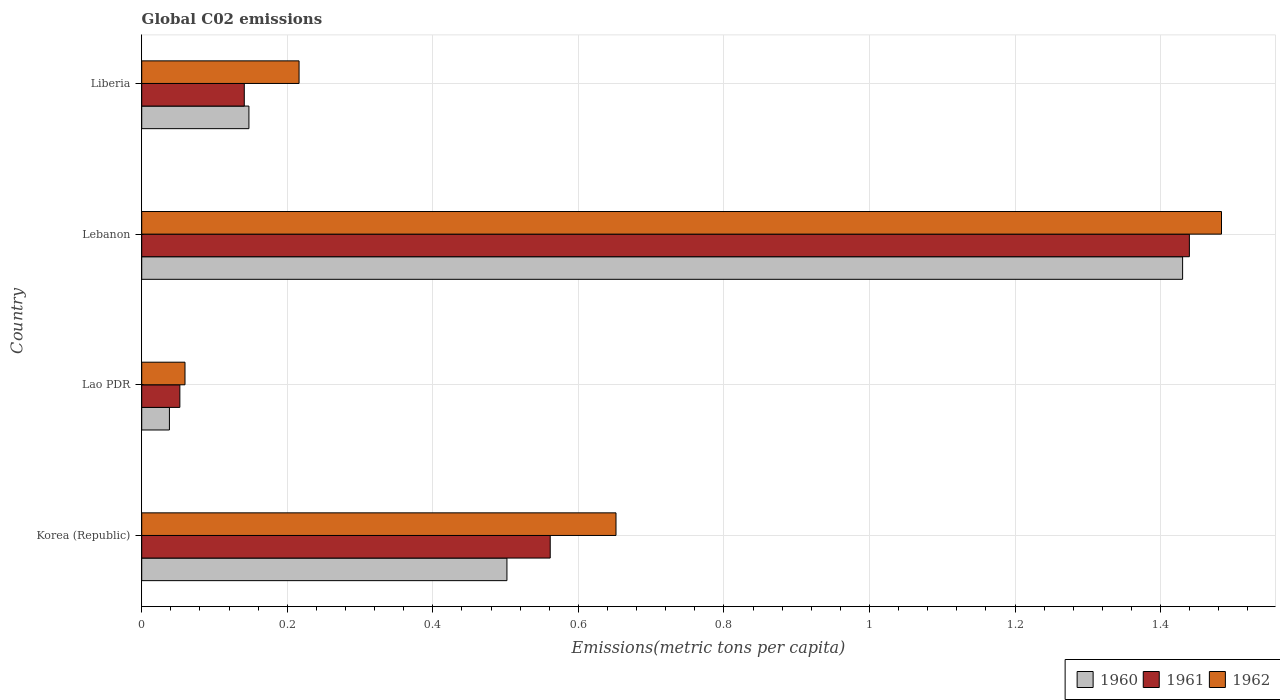Are the number of bars on each tick of the Y-axis equal?
Ensure brevity in your answer.  Yes. How many bars are there on the 2nd tick from the bottom?
Provide a succinct answer. 3. What is the amount of CO2 emitted in in 1962 in Korea (Republic)?
Keep it short and to the point. 0.65. Across all countries, what is the maximum amount of CO2 emitted in in 1960?
Keep it short and to the point. 1.43. Across all countries, what is the minimum amount of CO2 emitted in in 1962?
Keep it short and to the point. 0.06. In which country was the amount of CO2 emitted in in 1962 maximum?
Your response must be concise. Lebanon. In which country was the amount of CO2 emitted in in 1961 minimum?
Provide a short and direct response. Lao PDR. What is the total amount of CO2 emitted in in 1960 in the graph?
Give a very brief answer. 2.12. What is the difference between the amount of CO2 emitted in in 1961 in Korea (Republic) and that in Lao PDR?
Your answer should be compact. 0.51. What is the difference between the amount of CO2 emitted in in 1960 in Lebanon and the amount of CO2 emitted in in 1962 in Korea (Republic)?
Give a very brief answer. 0.78. What is the average amount of CO2 emitted in in 1961 per country?
Provide a short and direct response. 0.55. What is the difference between the amount of CO2 emitted in in 1960 and amount of CO2 emitted in in 1961 in Liberia?
Provide a short and direct response. 0.01. In how many countries, is the amount of CO2 emitted in in 1960 greater than 0.32 metric tons per capita?
Ensure brevity in your answer.  2. What is the ratio of the amount of CO2 emitted in in 1960 in Korea (Republic) to that in Lebanon?
Offer a terse response. 0.35. Is the difference between the amount of CO2 emitted in in 1960 in Lao PDR and Lebanon greater than the difference between the amount of CO2 emitted in in 1961 in Lao PDR and Lebanon?
Give a very brief answer. No. What is the difference between the highest and the second highest amount of CO2 emitted in in 1962?
Keep it short and to the point. 0.83. What is the difference between the highest and the lowest amount of CO2 emitted in in 1960?
Keep it short and to the point. 1.39. Is the sum of the amount of CO2 emitted in in 1962 in Korea (Republic) and Liberia greater than the maximum amount of CO2 emitted in in 1960 across all countries?
Provide a succinct answer. No. What does the 2nd bar from the top in Korea (Republic) represents?
Keep it short and to the point. 1961. What does the 2nd bar from the bottom in Lao PDR represents?
Your response must be concise. 1961. Are the values on the major ticks of X-axis written in scientific E-notation?
Make the answer very short. No. Does the graph contain any zero values?
Offer a terse response. No. Does the graph contain grids?
Give a very brief answer. Yes. Where does the legend appear in the graph?
Provide a short and direct response. Bottom right. How many legend labels are there?
Give a very brief answer. 3. What is the title of the graph?
Provide a short and direct response. Global C02 emissions. Does "1984" appear as one of the legend labels in the graph?
Offer a terse response. No. What is the label or title of the X-axis?
Keep it short and to the point. Emissions(metric tons per capita). What is the label or title of the Y-axis?
Your answer should be compact. Country. What is the Emissions(metric tons per capita) of 1960 in Korea (Republic)?
Ensure brevity in your answer.  0.5. What is the Emissions(metric tons per capita) in 1961 in Korea (Republic)?
Keep it short and to the point. 0.56. What is the Emissions(metric tons per capita) of 1962 in Korea (Republic)?
Ensure brevity in your answer.  0.65. What is the Emissions(metric tons per capita) of 1960 in Lao PDR?
Offer a very short reply. 0.04. What is the Emissions(metric tons per capita) in 1961 in Lao PDR?
Give a very brief answer. 0.05. What is the Emissions(metric tons per capita) of 1962 in Lao PDR?
Give a very brief answer. 0.06. What is the Emissions(metric tons per capita) of 1960 in Lebanon?
Provide a succinct answer. 1.43. What is the Emissions(metric tons per capita) of 1961 in Lebanon?
Give a very brief answer. 1.44. What is the Emissions(metric tons per capita) of 1962 in Lebanon?
Your answer should be very brief. 1.48. What is the Emissions(metric tons per capita) in 1960 in Liberia?
Ensure brevity in your answer.  0.15. What is the Emissions(metric tons per capita) of 1961 in Liberia?
Provide a succinct answer. 0.14. What is the Emissions(metric tons per capita) of 1962 in Liberia?
Offer a terse response. 0.22. Across all countries, what is the maximum Emissions(metric tons per capita) in 1960?
Your response must be concise. 1.43. Across all countries, what is the maximum Emissions(metric tons per capita) of 1961?
Provide a succinct answer. 1.44. Across all countries, what is the maximum Emissions(metric tons per capita) of 1962?
Ensure brevity in your answer.  1.48. Across all countries, what is the minimum Emissions(metric tons per capita) in 1960?
Make the answer very short. 0.04. Across all countries, what is the minimum Emissions(metric tons per capita) in 1961?
Keep it short and to the point. 0.05. Across all countries, what is the minimum Emissions(metric tons per capita) in 1962?
Offer a terse response. 0.06. What is the total Emissions(metric tons per capita) of 1960 in the graph?
Offer a very short reply. 2.12. What is the total Emissions(metric tons per capita) of 1961 in the graph?
Give a very brief answer. 2.19. What is the total Emissions(metric tons per capita) in 1962 in the graph?
Make the answer very short. 2.41. What is the difference between the Emissions(metric tons per capita) of 1960 in Korea (Republic) and that in Lao PDR?
Provide a succinct answer. 0.46. What is the difference between the Emissions(metric tons per capita) of 1961 in Korea (Republic) and that in Lao PDR?
Ensure brevity in your answer.  0.51. What is the difference between the Emissions(metric tons per capita) in 1962 in Korea (Republic) and that in Lao PDR?
Provide a short and direct response. 0.59. What is the difference between the Emissions(metric tons per capita) of 1960 in Korea (Republic) and that in Lebanon?
Ensure brevity in your answer.  -0.93. What is the difference between the Emissions(metric tons per capita) of 1961 in Korea (Republic) and that in Lebanon?
Provide a succinct answer. -0.88. What is the difference between the Emissions(metric tons per capita) of 1962 in Korea (Republic) and that in Lebanon?
Keep it short and to the point. -0.83. What is the difference between the Emissions(metric tons per capita) of 1960 in Korea (Republic) and that in Liberia?
Keep it short and to the point. 0.35. What is the difference between the Emissions(metric tons per capita) in 1961 in Korea (Republic) and that in Liberia?
Provide a succinct answer. 0.42. What is the difference between the Emissions(metric tons per capita) in 1962 in Korea (Republic) and that in Liberia?
Keep it short and to the point. 0.44. What is the difference between the Emissions(metric tons per capita) of 1960 in Lao PDR and that in Lebanon?
Your answer should be compact. -1.39. What is the difference between the Emissions(metric tons per capita) in 1961 in Lao PDR and that in Lebanon?
Offer a very short reply. -1.39. What is the difference between the Emissions(metric tons per capita) of 1962 in Lao PDR and that in Lebanon?
Provide a short and direct response. -1.42. What is the difference between the Emissions(metric tons per capita) of 1960 in Lao PDR and that in Liberia?
Offer a terse response. -0.11. What is the difference between the Emissions(metric tons per capita) of 1961 in Lao PDR and that in Liberia?
Offer a terse response. -0.09. What is the difference between the Emissions(metric tons per capita) in 1962 in Lao PDR and that in Liberia?
Offer a terse response. -0.16. What is the difference between the Emissions(metric tons per capita) in 1960 in Lebanon and that in Liberia?
Your answer should be compact. 1.28. What is the difference between the Emissions(metric tons per capita) in 1961 in Lebanon and that in Liberia?
Your answer should be very brief. 1.3. What is the difference between the Emissions(metric tons per capita) in 1962 in Lebanon and that in Liberia?
Make the answer very short. 1.27. What is the difference between the Emissions(metric tons per capita) of 1960 in Korea (Republic) and the Emissions(metric tons per capita) of 1961 in Lao PDR?
Offer a very short reply. 0.45. What is the difference between the Emissions(metric tons per capita) of 1960 in Korea (Republic) and the Emissions(metric tons per capita) of 1962 in Lao PDR?
Ensure brevity in your answer.  0.44. What is the difference between the Emissions(metric tons per capita) in 1961 in Korea (Republic) and the Emissions(metric tons per capita) in 1962 in Lao PDR?
Give a very brief answer. 0.5. What is the difference between the Emissions(metric tons per capita) in 1960 in Korea (Republic) and the Emissions(metric tons per capita) in 1961 in Lebanon?
Ensure brevity in your answer.  -0.94. What is the difference between the Emissions(metric tons per capita) of 1960 in Korea (Republic) and the Emissions(metric tons per capita) of 1962 in Lebanon?
Your answer should be very brief. -0.98. What is the difference between the Emissions(metric tons per capita) of 1961 in Korea (Republic) and the Emissions(metric tons per capita) of 1962 in Lebanon?
Offer a terse response. -0.92. What is the difference between the Emissions(metric tons per capita) in 1960 in Korea (Republic) and the Emissions(metric tons per capita) in 1961 in Liberia?
Your answer should be compact. 0.36. What is the difference between the Emissions(metric tons per capita) of 1960 in Korea (Republic) and the Emissions(metric tons per capita) of 1962 in Liberia?
Your answer should be compact. 0.29. What is the difference between the Emissions(metric tons per capita) in 1961 in Korea (Republic) and the Emissions(metric tons per capita) in 1962 in Liberia?
Your answer should be compact. 0.35. What is the difference between the Emissions(metric tons per capita) in 1960 in Lao PDR and the Emissions(metric tons per capita) in 1961 in Lebanon?
Provide a short and direct response. -1.4. What is the difference between the Emissions(metric tons per capita) in 1960 in Lao PDR and the Emissions(metric tons per capita) in 1962 in Lebanon?
Ensure brevity in your answer.  -1.45. What is the difference between the Emissions(metric tons per capita) in 1961 in Lao PDR and the Emissions(metric tons per capita) in 1962 in Lebanon?
Make the answer very short. -1.43. What is the difference between the Emissions(metric tons per capita) in 1960 in Lao PDR and the Emissions(metric tons per capita) in 1961 in Liberia?
Your answer should be compact. -0.1. What is the difference between the Emissions(metric tons per capita) in 1960 in Lao PDR and the Emissions(metric tons per capita) in 1962 in Liberia?
Offer a very short reply. -0.18. What is the difference between the Emissions(metric tons per capita) of 1961 in Lao PDR and the Emissions(metric tons per capita) of 1962 in Liberia?
Keep it short and to the point. -0.16. What is the difference between the Emissions(metric tons per capita) in 1960 in Lebanon and the Emissions(metric tons per capita) in 1961 in Liberia?
Your answer should be compact. 1.29. What is the difference between the Emissions(metric tons per capita) of 1960 in Lebanon and the Emissions(metric tons per capita) of 1962 in Liberia?
Offer a terse response. 1.21. What is the difference between the Emissions(metric tons per capita) in 1961 in Lebanon and the Emissions(metric tons per capita) in 1962 in Liberia?
Your answer should be very brief. 1.22. What is the average Emissions(metric tons per capita) in 1960 per country?
Your answer should be very brief. 0.53. What is the average Emissions(metric tons per capita) in 1961 per country?
Your response must be concise. 0.55. What is the average Emissions(metric tons per capita) of 1962 per country?
Offer a terse response. 0.6. What is the difference between the Emissions(metric tons per capita) of 1960 and Emissions(metric tons per capita) of 1961 in Korea (Republic)?
Offer a very short reply. -0.06. What is the difference between the Emissions(metric tons per capita) of 1960 and Emissions(metric tons per capita) of 1962 in Korea (Republic)?
Provide a succinct answer. -0.15. What is the difference between the Emissions(metric tons per capita) in 1961 and Emissions(metric tons per capita) in 1962 in Korea (Republic)?
Your answer should be compact. -0.09. What is the difference between the Emissions(metric tons per capita) of 1960 and Emissions(metric tons per capita) of 1961 in Lao PDR?
Offer a terse response. -0.01. What is the difference between the Emissions(metric tons per capita) in 1960 and Emissions(metric tons per capita) in 1962 in Lao PDR?
Give a very brief answer. -0.02. What is the difference between the Emissions(metric tons per capita) of 1961 and Emissions(metric tons per capita) of 1962 in Lao PDR?
Give a very brief answer. -0.01. What is the difference between the Emissions(metric tons per capita) of 1960 and Emissions(metric tons per capita) of 1961 in Lebanon?
Provide a succinct answer. -0.01. What is the difference between the Emissions(metric tons per capita) of 1960 and Emissions(metric tons per capita) of 1962 in Lebanon?
Give a very brief answer. -0.05. What is the difference between the Emissions(metric tons per capita) of 1961 and Emissions(metric tons per capita) of 1962 in Lebanon?
Provide a succinct answer. -0.04. What is the difference between the Emissions(metric tons per capita) of 1960 and Emissions(metric tons per capita) of 1961 in Liberia?
Offer a very short reply. 0.01. What is the difference between the Emissions(metric tons per capita) in 1960 and Emissions(metric tons per capita) in 1962 in Liberia?
Your response must be concise. -0.07. What is the difference between the Emissions(metric tons per capita) in 1961 and Emissions(metric tons per capita) in 1962 in Liberia?
Offer a terse response. -0.08. What is the ratio of the Emissions(metric tons per capita) in 1960 in Korea (Republic) to that in Lao PDR?
Your response must be concise. 13.19. What is the ratio of the Emissions(metric tons per capita) of 1961 in Korea (Republic) to that in Lao PDR?
Your response must be concise. 10.71. What is the ratio of the Emissions(metric tons per capita) in 1962 in Korea (Republic) to that in Lao PDR?
Offer a terse response. 10.96. What is the ratio of the Emissions(metric tons per capita) of 1960 in Korea (Republic) to that in Lebanon?
Provide a succinct answer. 0.35. What is the ratio of the Emissions(metric tons per capita) of 1961 in Korea (Republic) to that in Lebanon?
Give a very brief answer. 0.39. What is the ratio of the Emissions(metric tons per capita) of 1962 in Korea (Republic) to that in Lebanon?
Your answer should be very brief. 0.44. What is the ratio of the Emissions(metric tons per capita) of 1960 in Korea (Republic) to that in Liberia?
Your response must be concise. 3.41. What is the ratio of the Emissions(metric tons per capita) in 1961 in Korea (Republic) to that in Liberia?
Your answer should be very brief. 3.98. What is the ratio of the Emissions(metric tons per capita) of 1962 in Korea (Republic) to that in Liberia?
Your answer should be very brief. 3.01. What is the ratio of the Emissions(metric tons per capita) of 1960 in Lao PDR to that in Lebanon?
Ensure brevity in your answer.  0.03. What is the ratio of the Emissions(metric tons per capita) in 1961 in Lao PDR to that in Lebanon?
Offer a terse response. 0.04. What is the ratio of the Emissions(metric tons per capita) in 1962 in Lao PDR to that in Lebanon?
Offer a terse response. 0.04. What is the ratio of the Emissions(metric tons per capita) in 1960 in Lao PDR to that in Liberia?
Provide a succinct answer. 0.26. What is the ratio of the Emissions(metric tons per capita) of 1961 in Lao PDR to that in Liberia?
Offer a very short reply. 0.37. What is the ratio of the Emissions(metric tons per capita) in 1962 in Lao PDR to that in Liberia?
Make the answer very short. 0.28. What is the ratio of the Emissions(metric tons per capita) of 1960 in Lebanon to that in Liberia?
Your answer should be compact. 9.71. What is the ratio of the Emissions(metric tons per capita) in 1961 in Lebanon to that in Liberia?
Your answer should be very brief. 10.21. What is the ratio of the Emissions(metric tons per capita) of 1962 in Lebanon to that in Liberia?
Keep it short and to the point. 6.86. What is the difference between the highest and the second highest Emissions(metric tons per capita) of 1960?
Offer a very short reply. 0.93. What is the difference between the highest and the second highest Emissions(metric tons per capita) of 1961?
Provide a short and direct response. 0.88. What is the difference between the highest and the second highest Emissions(metric tons per capita) in 1962?
Your response must be concise. 0.83. What is the difference between the highest and the lowest Emissions(metric tons per capita) of 1960?
Keep it short and to the point. 1.39. What is the difference between the highest and the lowest Emissions(metric tons per capita) in 1961?
Your response must be concise. 1.39. What is the difference between the highest and the lowest Emissions(metric tons per capita) of 1962?
Provide a succinct answer. 1.42. 